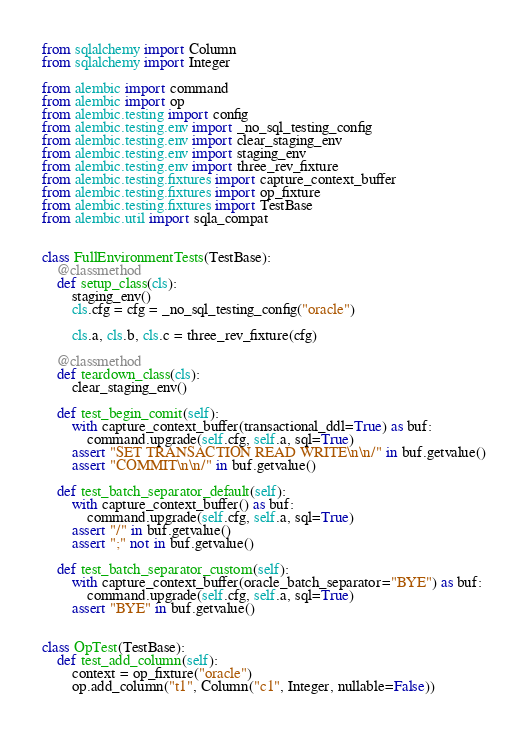Convert code to text. <code><loc_0><loc_0><loc_500><loc_500><_Python_>from sqlalchemy import Column
from sqlalchemy import Integer

from alembic import command
from alembic import op
from alembic.testing import config
from alembic.testing.env import _no_sql_testing_config
from alembic.testing.env import clear_staging_env
from alembic.testing.env import staging_env
from alembic.testing.env import three_rev_fixture
from alembic.testing.fixtures import capture_context_buffer
from alembic.testing.fixtures import op_fixture
from alembic.testing.fixtures import TestBase
from alembic.util import sqla_compat


class FullEnvironmentTests(TestBase):
    @classmethod
    def setup_class(cls):
        staging_env()
        cls.cfg = cfg = _no_sql_testing_config("oracle")

        cls.a, cls.b, cls.c = three_rev_fixture(cfg)

    @classmethod
    def teardown_class(cls):
        clear_staging_env()

    def test_begin_comit(self):
        with capture_context_buffer(transactional_ddl=True) as buf:
            command.upgrade(self.cfg, self.a, sql=True)
        assert "SET TRANSACTION READ WRITE\n\n/" in buf.getvalue()
        assert "COMMIT\n\n/" in buf.getvalue()

    def test_batch_separator_default(self):
        with capture_context_buffer() as buf:
            command.upgrade(self.cfg, self.a, sql=True)
        assert "/" in buf.getvalue()
        assert ";" not in buf.getvalue()

    def test_batch_separator_custom(self):
        with capture_context_buffer(oracle_batch_separator="BYE") as buf:
            command.upgrade(self.cfg, self.a, sql=True)
        assert "BYE" in buf.getvalue()


class OpTest(TestBase):
    def test_add_column(self):
        context = op_fixture("oracle")
        op.add_column("t1", Column("c1", Integer, nullable=False))</code> 